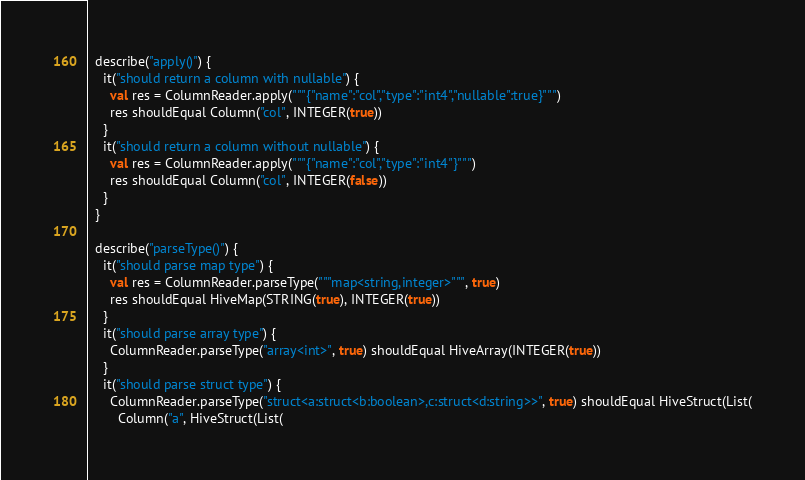<code> <loc_0><loc_0><loc_500><loc_500><_Scala_>  describe("apply()") {
    it("should return a column with nullable") {
      val res = ColumnReader.apply("""{"name":"col","type":"int4","nullable":true}""")
      res shouldEqual Column("col", INTEGER(true))
    }
    it("should return a column without nullable") {
      val res = ColumnReader.apply("""{"name":"col","type":"int4"}""")
      res shouldEqual Column("col", INTEGER(false))
    }
  }

  describe("parseType()") {
    it("should parse map type") {
      val res = ColumnReader.parseType("""map<string,integer>""", true)
      res shouldEqual HiveMap(STRING(true), INTEGER(true))
    }
    it("should parse array type") {
      ColumnReader.parseType("array<int>", true) shouldEqual HiveArray(INTEGER(true))
    }
    it("should parse struct type") {
      ColumnReader.parseType("struct<a:struct<b:boolean>,c:struct<d:string>>", true) shouldEqual HiveStruct(List(
        Column("a", HiveStruct(List(</code> 